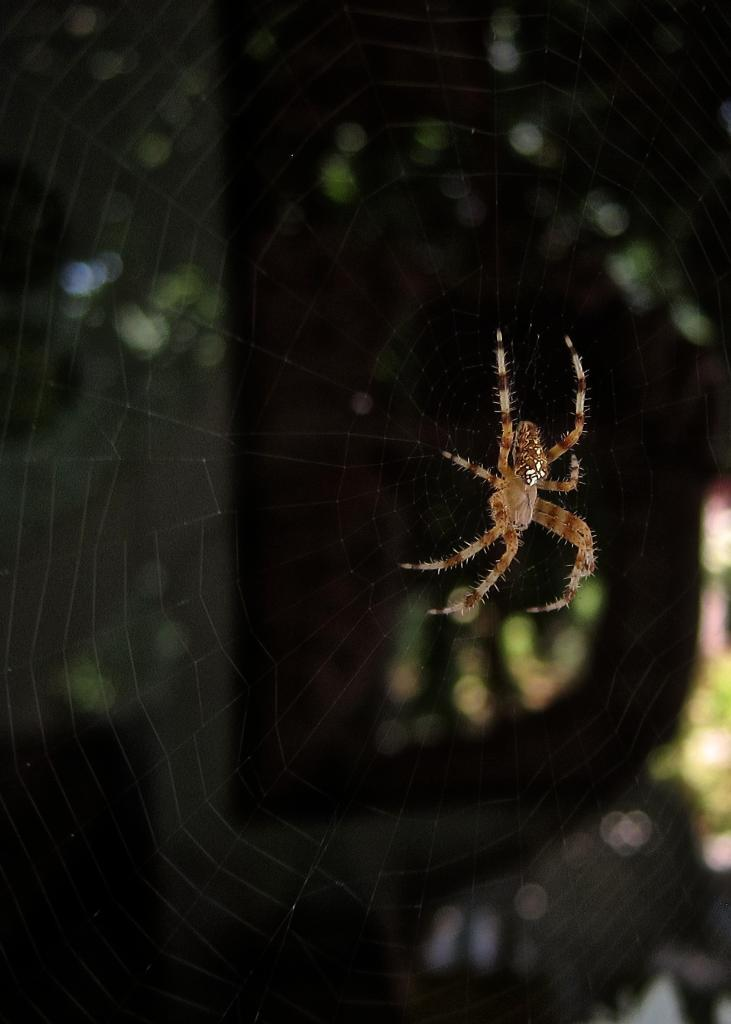What is the main subject of the image? There is a spider in the image. Where is the spider located? The spider is on a web. Can you describe the background of the image? The background of the image is blurred. What is the temperature of the earth in the image? There is no indication of the temperature or the earth in the image; it features a spider on a web with a blurred background. 